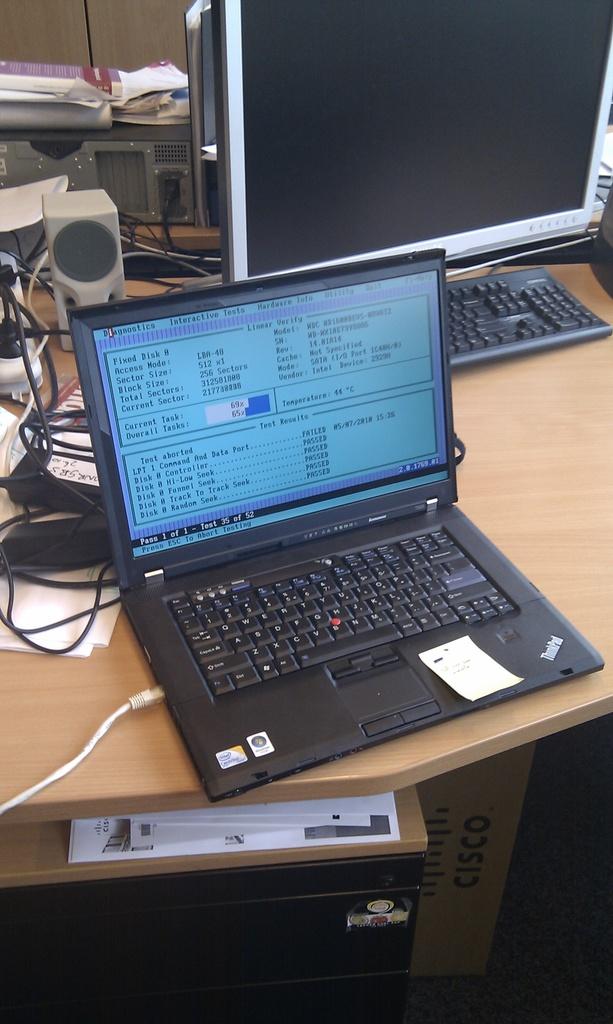What is written on the box under the desk?
Provide a succinct answer. Cisco. 